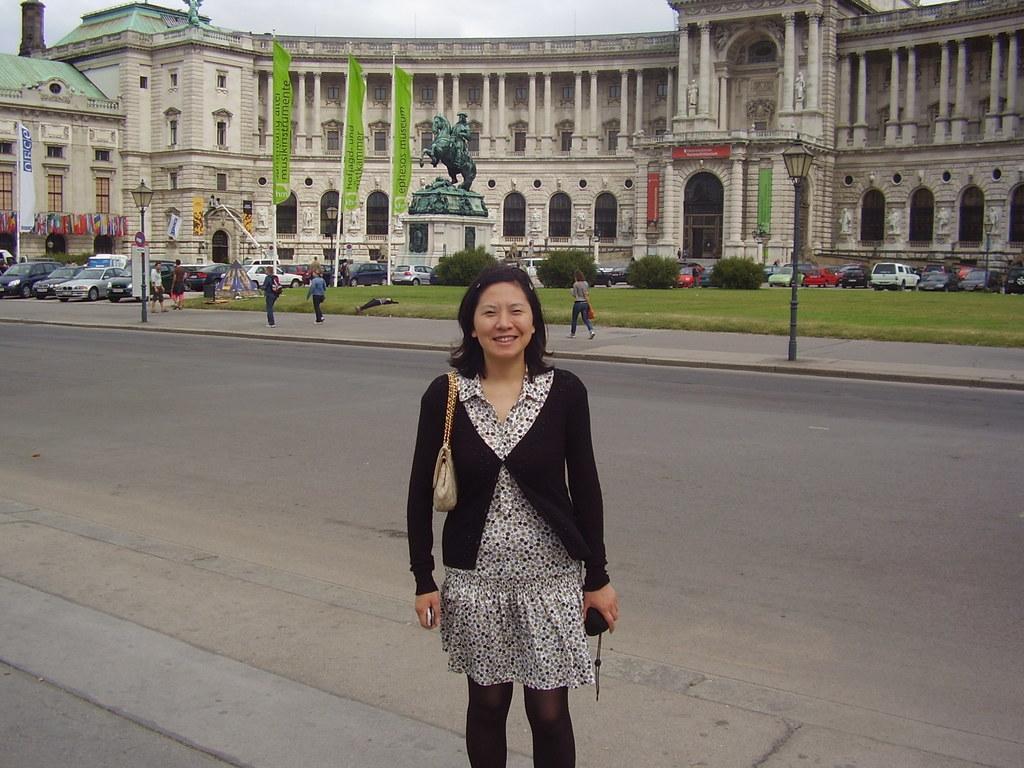How would you summarize this image in a sentence or two? In this picture we can observe a woman standing and smiling. She is wearing black and white color dress. Behind her there is a road. We can observe some people walking on the footpath. There are two street light poles. There are some cars parked. We can observe a statue of a horse. In the background there is a building and there are three green color flags. We can observe a sky here. 